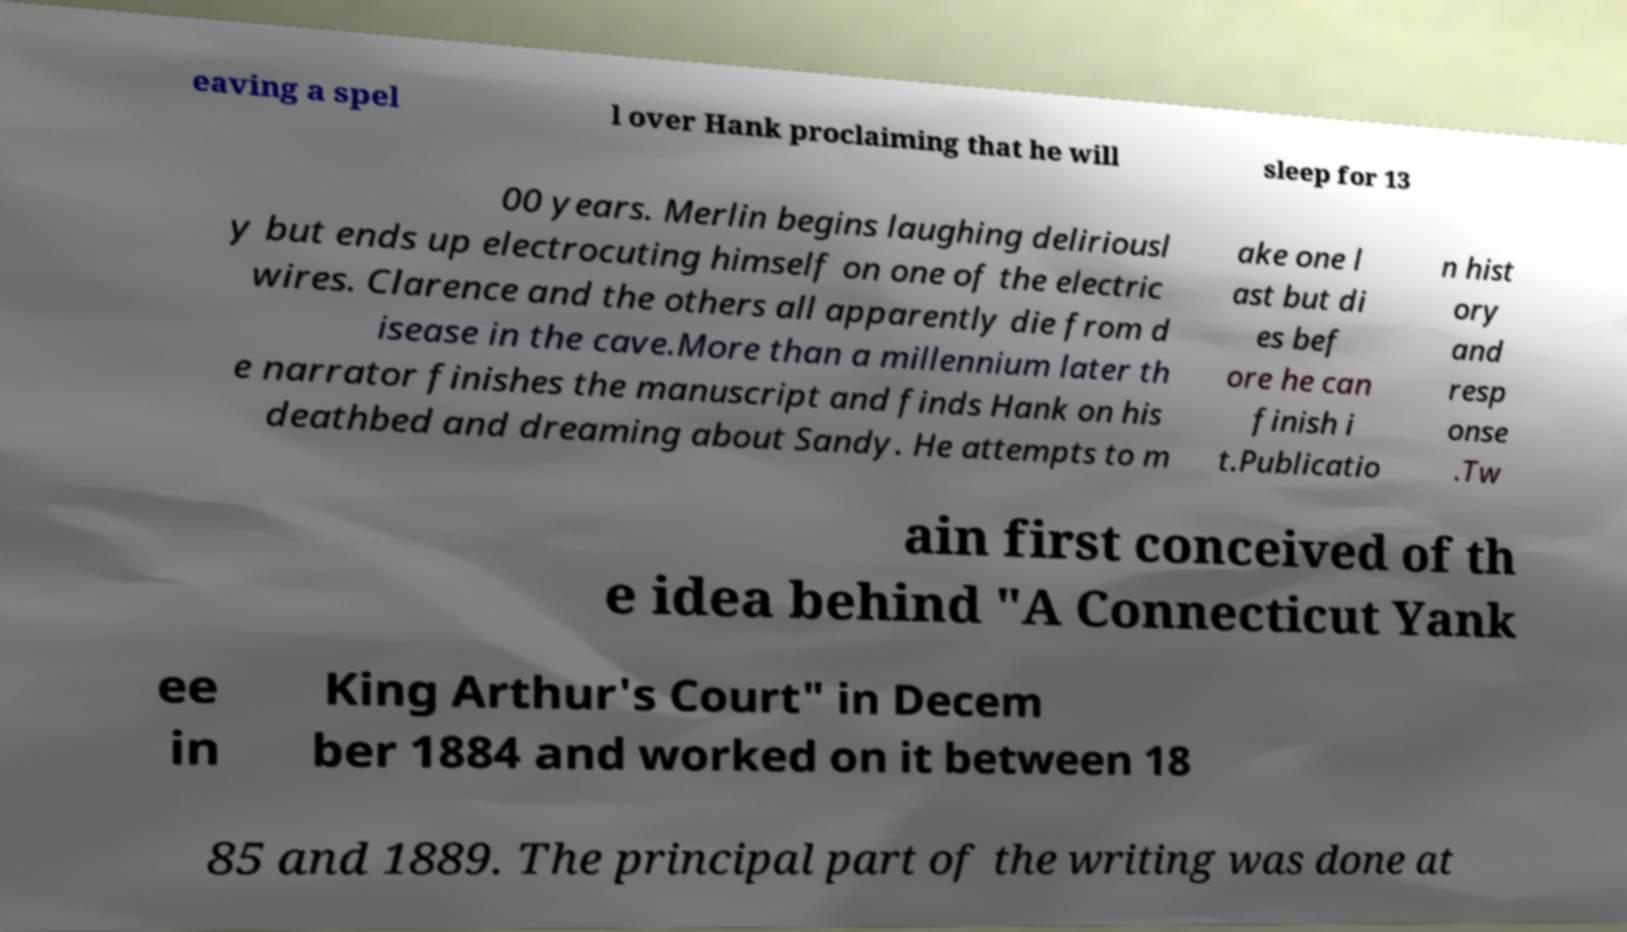For documentation purposes, I need the text within this image transcribed. Could you provide that? eaving a spel l over Hank proclaiming that he will sleep for 13 00 years. Merlin begins laughing deliriousl y but ends up electrocuting himself on one of the electric wires. Clarence and the others all apparently die from d isease in the cave.More than a millennium later th e narrator finishes the manuscript and finds Hank on his deathbed and dreaming about Sandy. He attempts to m ake one l ast but di es bef ore he can finish i t.Publicatio n hist ory and resp onse .Tw ain first conceived of th e idea behind "A Connecticut Yank ee in King Arthur's Court" in Decem ber 1884 and worked on it between 18 85 and 1889. The principal part of the writing was done at 